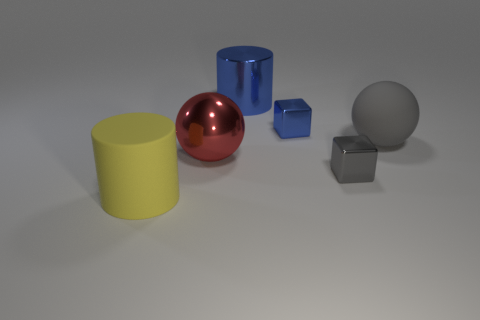The other tiny shiny thing that is the same shape as the tiny blue metal object is what color?
Offer a terse response. Gray. What color is the large object on the right side of the cylinder that is right of the red sphere?
Ensure brevity in your answer.  Gray. The large yellow matte thing is what shape?
Ensure brevity in your answer.  Cylinder. There is a large object that is to the right of the red metal object and in front of the large blue metallic object; what shape is it?
Offer a very short reply. Sphere. What is the color of the large cylinder that is the same material as the tiny blue block?
Offer a very short reply. Blue. What is the shape of the yellow object that is in front of the big red metallic object on the left side of the gray metal block that is to the right of the large yellow cylinder?
Provide a succinct answer. Cylinder. The red ball is what size?
Make the answer very short. Large. What shape is the yellow object that is the same material as the big gray ball?
Your answer should be compact. Cylinder. Are there fewer big balls to the right of the large shiny cylinder than red spheres?
Offer a terse response. No. What color is the big cylinder that is on the left side of the metallic cylinder?
Provide a succinct answer. Yellow. 